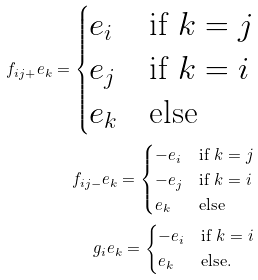<formula> <loc_0><loc_0><loc_500><loc_500>f _ { i j + } e _ { k } = \begin{cases} e _ { i } & \text {if } k = j \\ e _ { j } & \text {if } k = i \\ e _ { k } & \text {else} \end{cases} \\ f _ { i j - } e _ { k } = \begin{cases} - e _ { i } & \text {if } k = j \\ - e _ { j } & \text {if } k = i \\ e _ { k } & \text {else} \end{cases} \\ g _ { i } e _ { k } = \begin{cases} - e _ { i } & \text {if } k = i \\ e _ { k } & \text {else} . \end{cases}</formula> 